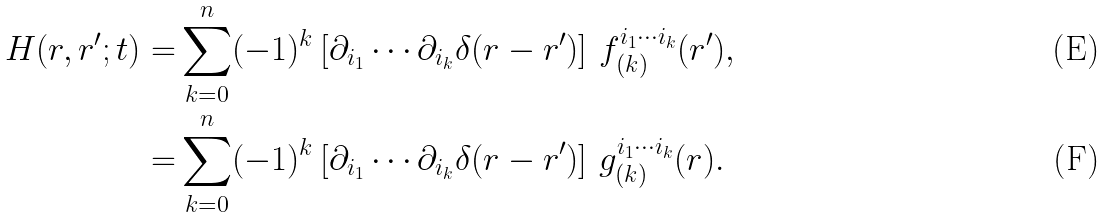<formula> <loc_0><loc_0><loc_500><loc_500>H ( r , r ^ { \prime } ; t ) = & \sum _ { k = 0 } ^ { n } ( - 1 ) ^ { k } \left [ \partial _ { i _ { 1 } } \cdots \partial _ { i _ { k } } \delta ( r - r ^ { \prime } ) \right ] \, f _ { ( k ) } ^ { i _ { 1 } \cdots i _ { k } } ( r ^ { \prime } ) , \\ = & \sum _ { k = 0 } ^ { n } ( - 1 ) ^ { k } \left [ \partial _ { i _ { 1 } } \cdots \partial _ { i _ { k } } \delta ( r - r ^ { \prime } ) \right ] \, g _ { ( k ) } ^ { i _ { 1 } \cdots i _ { k } } ( r ) .</formula> 